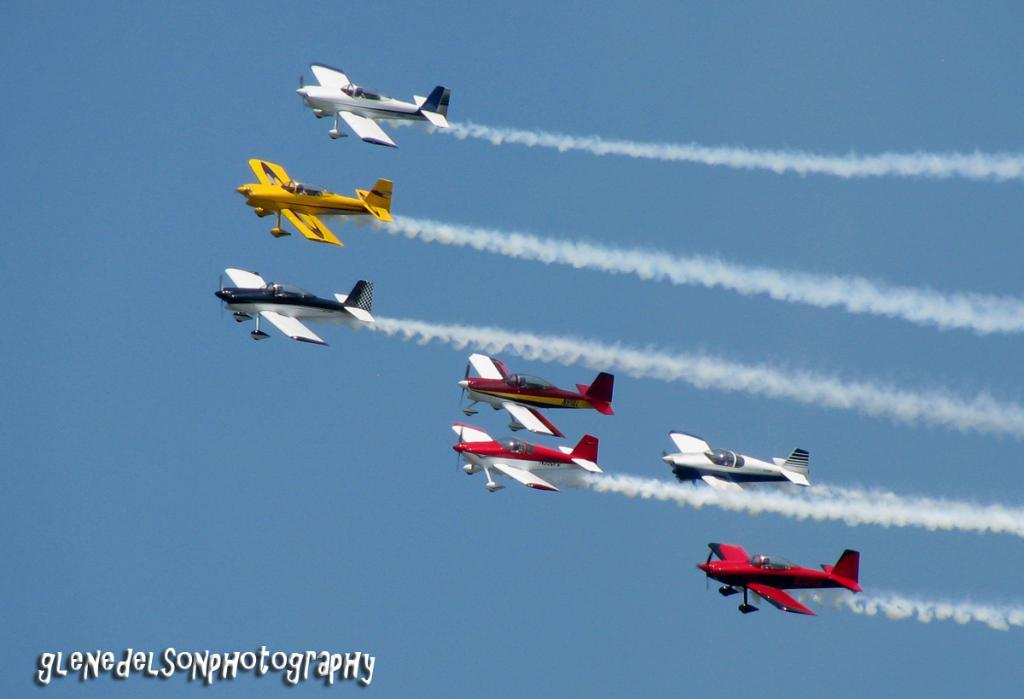What is happening in the image? There are airplanes flying in the image. What can be seen in the background of the image? The sky is visible in the background of the image. Is there any additional information about the image's appearance? Yes, there is a water mark at the bottom of the image. How many apples are sitting on the stem in the image? There are no apples or stems present in the image. What type of toad can be seen hopping in the image? There are no toads present in the image. 